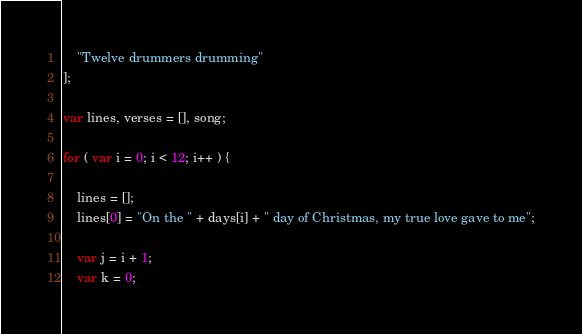<code> <loc_0><loc_0><loc_500><loc_500><_JavaScript_>    "Twelve drummers drumming"
];

var lines, verses = [], song;

for ( var i = 0; i < 12; i++ ) {

    lines = [];
    lines[0] = "On the " + days[i] + " day of Christmas, my true love gave to me";

    var j = i + 1;
    var k = 0;</code> 